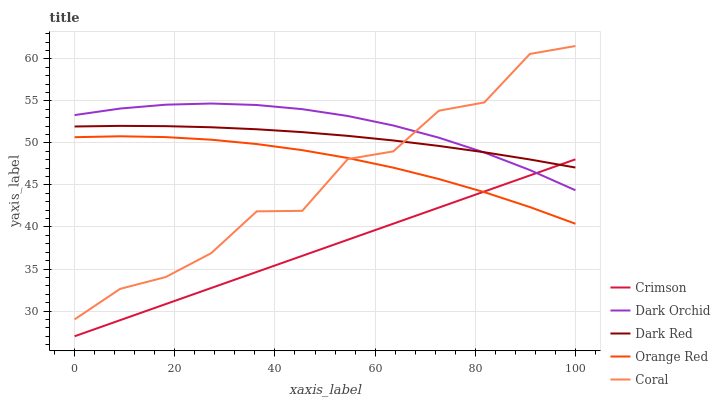Does Dark Red have the minimum area under the curve?
Answer yes or no. No. Does Dark Red have the maximum area under the curve?
Answer yes or no. No. Is Dark Red the smoothest?
Answer yes or no. No. Is Dark Red the roughest?
Answer yes or no. No. Does Coral have the lowest value?
Answer yes or no. No. Does Dark Red have the highest value?
Answer yes or no. No. Is Orange Red less than Dark Orchid?
Answer yes or no. Yes. Is Dark Orchid greater than Orange Red?
Answer yes or no. Yes. Does Orange Red intersect Dark Orchid?
Answer yes or no. No. 